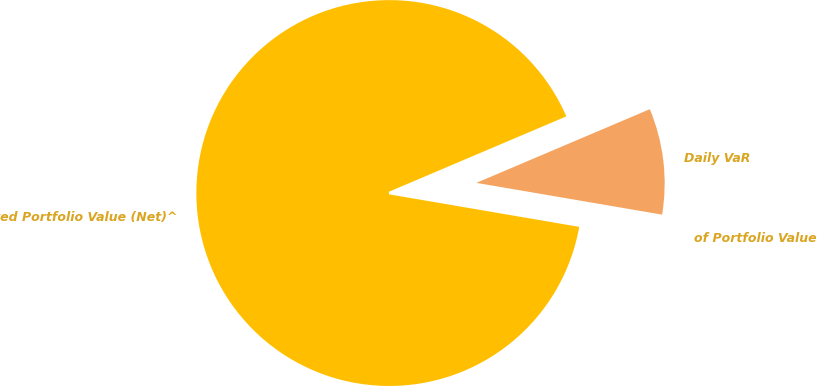Convert chart to OTSL. <chart><loc_0><loc_0><loc_500><loc_500><pie_chart><fcel>Daily VaR<fcel>Related Portfolio Value (Net)^<fcel>of Portfolio Value<nl><fcel>9.09%<fcel>90.91%<fcel>0.0%<nl></chart> 